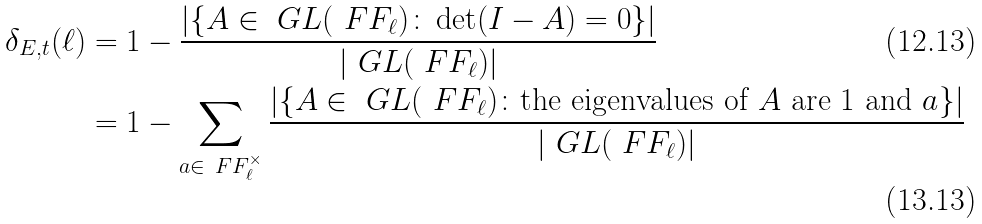<formula> <loc_0><loc_0><loc_500><loc_500>\delta _ { E , t } ( \ell ) & = 1 - \frac { | \{ A \in \ G L ( \ F F _ { \ell } ) \colon \det ( I - A ) = 0 \} | } { | \ G L ( \ F F _ { \ell } ) | } \\ & = 1 - \sum _ { a \in \ F F _ { \ell } ^ { \times } } \frac { | \{ A \in \ G L ( \ F F _ { \ell } ) \colon \text {the eigenvalues of $A$ are $1$ and $a$} \} | } { | \ G L ( \ F F _ { \ell } ) | }</formula> 